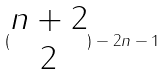Convert formula to latex. <formula><loc_0><loc_0><loc_500><loc_500>( \begin{matrix} n + 2 \\ 2 \end{matrix} ) - 2 n - 1</formula> 